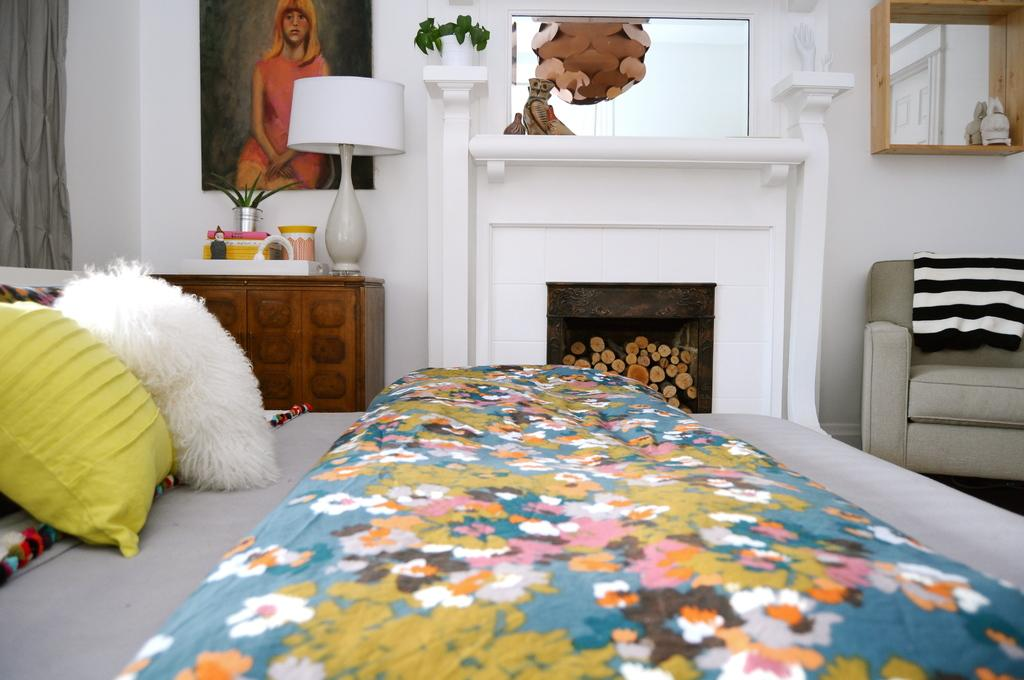What type of space is shown in the image? The image depicts a room. What piece of furniture is present in the room for sleeping? There is a bed in the room. What are the pillows used for on the bed? The pillows are used for comfort and support while sleeping on the bed. What type of artwork is present in the room? There is a painting in the room. What type of decorative item is present in the room for holding flowers? There is a flower vase in the room. What type of seating is present in the room for relaxation? There is a couch in the room. What type of veil is draped over the sofa in the image? There is no veil present in the image, and the couch is referred to as a couch, not a sofa. 